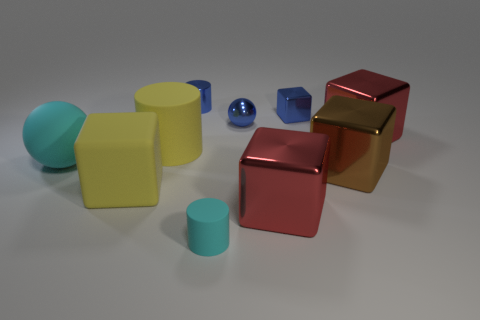Subtract all blue shiny cubes. How many cubes are left? 4 Subtract all blue cubes. How many cubes are left? 4 Subtract all purple cubes. Subtract all gray cylinders. How many cubes are left? 5 Subtract all balls. How many objects are left? 8 Subtract all tiny cyan things. Subtract all tiny rubber cylinders. How many objects are left? 8 Add 5 yellow things. How many yellow things are left? 7 Add 3 tiny brown cylinders. How many tiny brown cylinders exist? 3 Subtract 1 brown blocks. How many objects are left? 9 